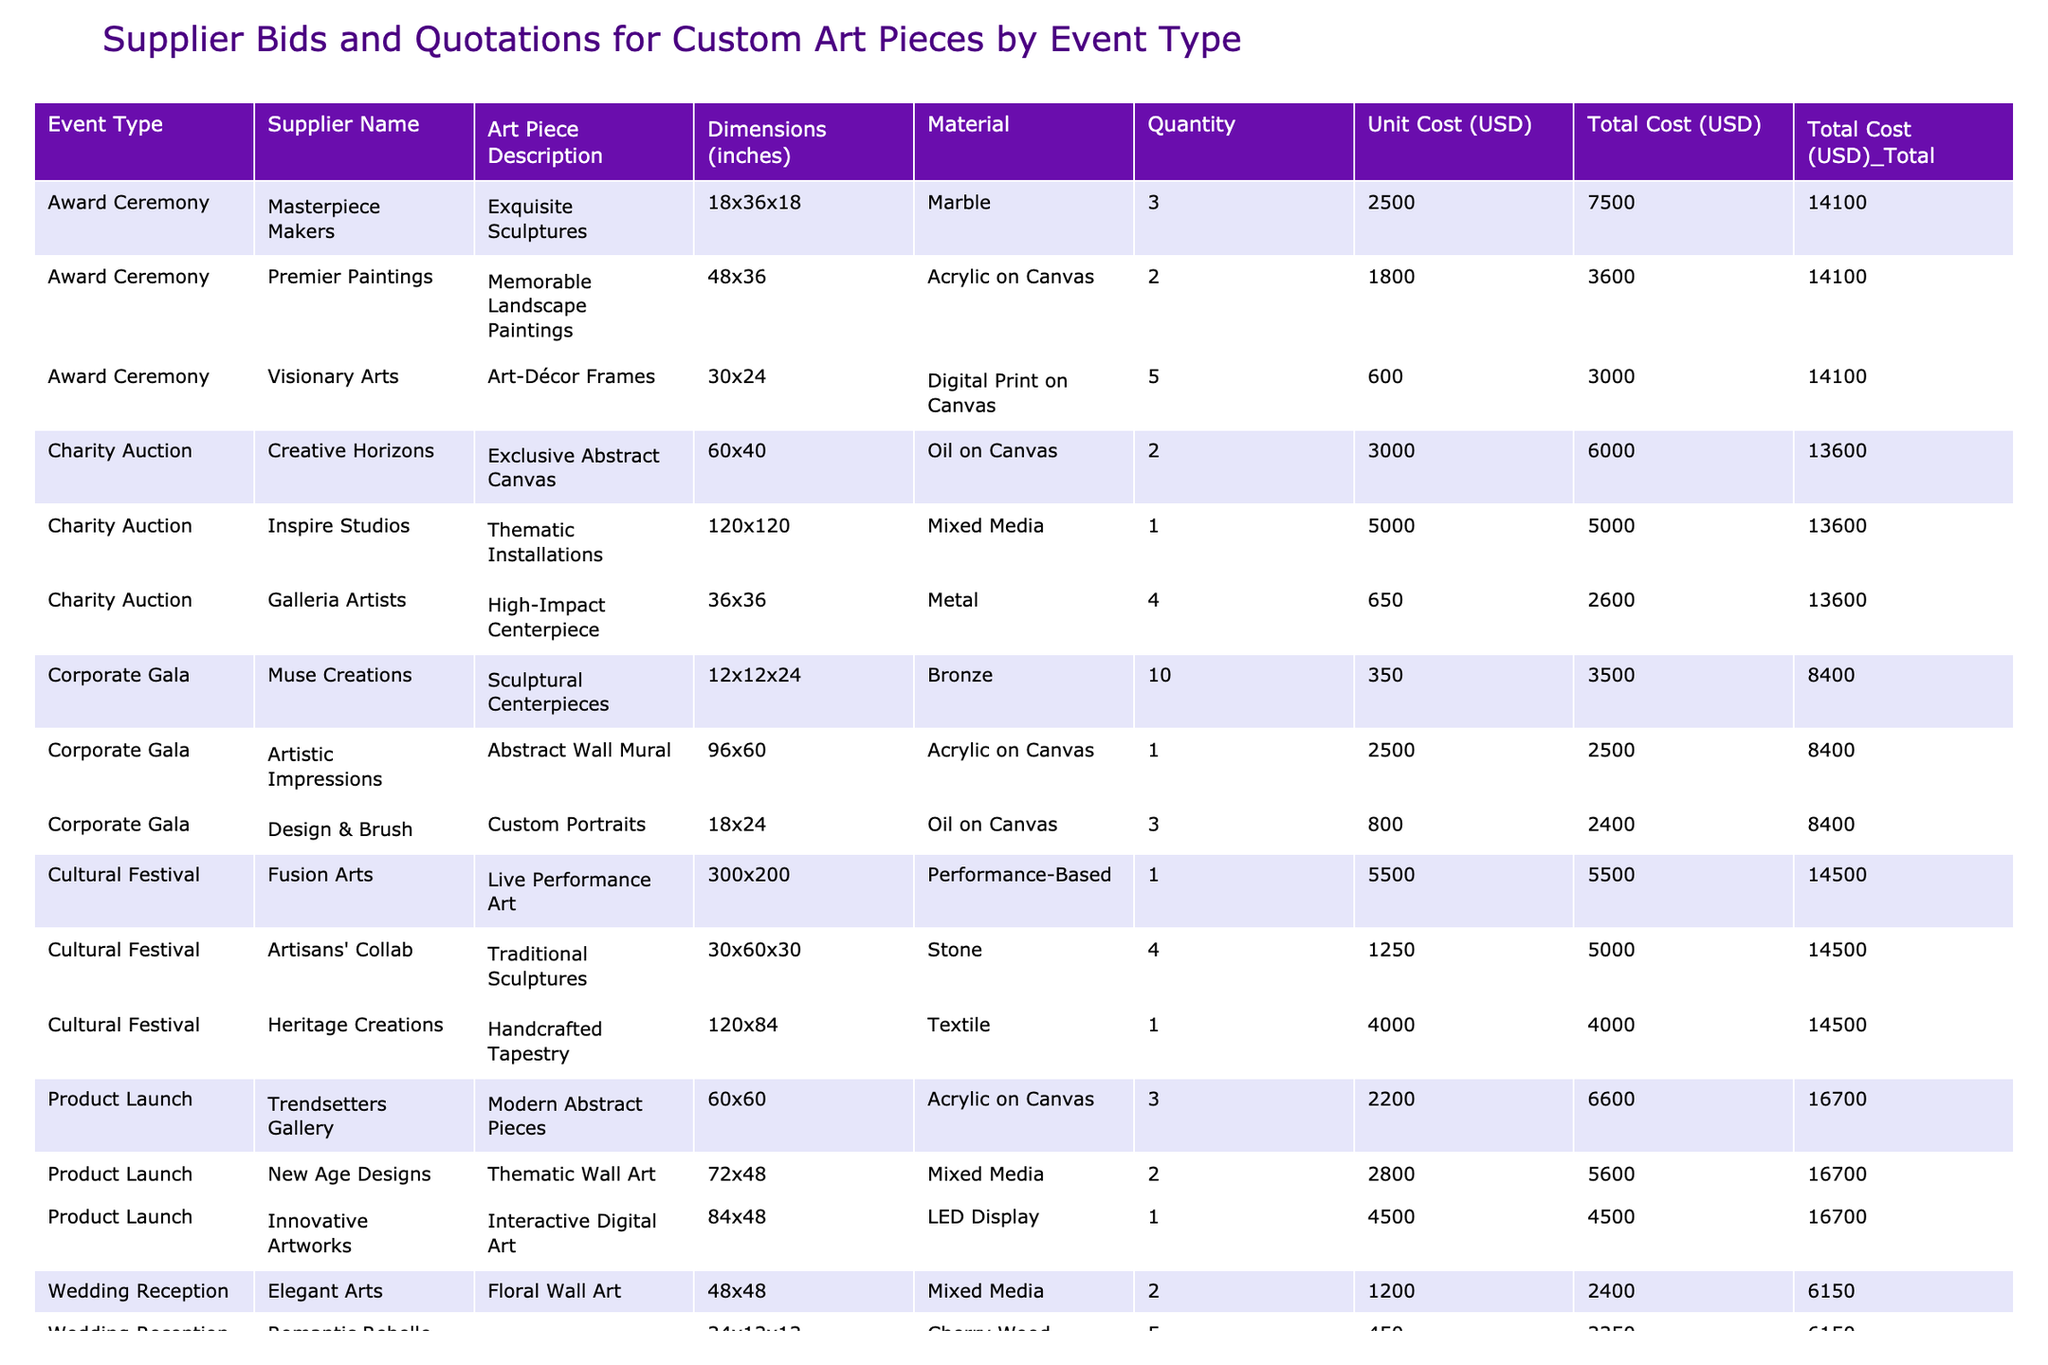What is the total cost of custom art pieces for the Corporate Gala? To find the total cost for the Corporate Gala, I look for all entries under that event type in the table. The relevant total costs are 2500, 3500, and 2400. Adding these together: 2500 + 3500 + 2400 = 8400.
Answer: 8400 Which supplier provided the most expensive art piece for the Wedding Reception? In the Wedding Reception category, I examine the total costs of each art piece. The costs are 2400, 2250, and 1500. The highest total cost is 2400, provided by Elegant Arts for Floral Wall Art.
Answer: Elegant Arts How many different suppliers submitted bids for the Charity Auction? I check the Charity Auction section and identify the suppliers listed, which are Inspire Studios, Creative Horizons, and Galleria Artists. Counting these gives us a total of 3 unique suppliers.
Answer: 3 What is the average unit cost of art pieces for the Award Ceremony? I look at the unit costs for the Award Ceremony: 2500, 600, and 1800. First, I calculate the total: 2500 + 600 + 1800 = 4900. Then, I divide this by the number of suppliers, which is 3. Thus, the average unit cost is 4900 / 3 = 1633.33.
Answer: 1633.33 Is there a custom art piece with a quantity of 1 for the Product Launch? I scan through the Product Launch section and find the art pieces listed. The only piece with a quantity of 1 is the Interactive Digital Art by Innovative Artworks. Therefore, the answer is yes.
Answer: Yes What is the total quantity of art pieces for the Cultural Festival? I review the Cultural Festival entries which have quantities of 4 (Traditional Sculptures), 1 (Handcrafted Tapestry), and 1 (Live Performance Art). Summing these gives: 4 + 1 + 1 = 6.
Answer: 6 Which event type has the highest overall total cost and what is that amount? I calculate the total costs for each event type. Corporate Gala totals 8400, Wedding Reception totals 6150, Charity Auction totals 13600, Award Ceremony totals 4900, Product Launch totals 14600, and Cultural Festival totals 9500. The Product Launch has the highest total cost at 14600.
Answer: Product Launch: 14600 What is the difference in total cost between the Charity Auction and Wedding Reception? The total cost for Charity Auction is 13600, and for Wedding Reception, it is 6150. To find the difference: 13600 - 6150 = 7450.
Answer: 7450 Do any art pieces for the Corporate Gala have a unit cost under 1000? Examining the Corporate Gala section, the costs are 2500, 350, and 800. None of these costs fall below 1000, leading to a negative answer.
Answer: No 